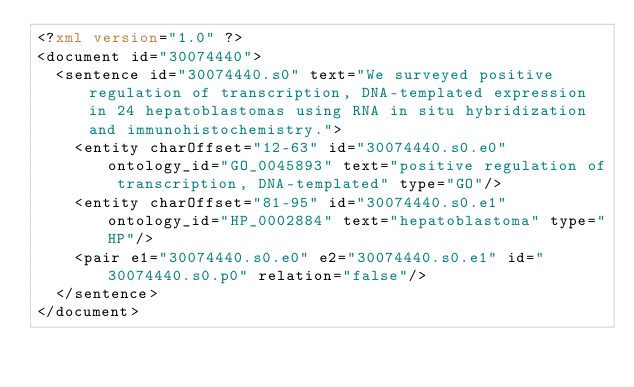<code> <loc_0><loc_0><loc_500><loc_500><_XML_><?xml version="1.0" ?>
<document id="30074440">
  <sentence id="30074440.s0" text="We surveyed positive regulation of transcription, DNA-templated expression in 24 hepatoblastomas using RNA in situ hybridization and immunohistochemistry.">
    <entity charOffset="12-63" id="30074440.s0.e0" ontology_id="GO_0045893" text="positive regulation of transcription, DNA-templated" type="GO"/>
    <entity charOffset="81-95" id="30074440.s0.e1" ontology_id="HP_0002884" text="hepatoblastoma" type="HP"/>
    <pair e1="30074440.s0.e0" e2="30074440.s0.e1" id="30074440.s0.p0" relation="false"/>
  </sentence>
</document>
</code> 